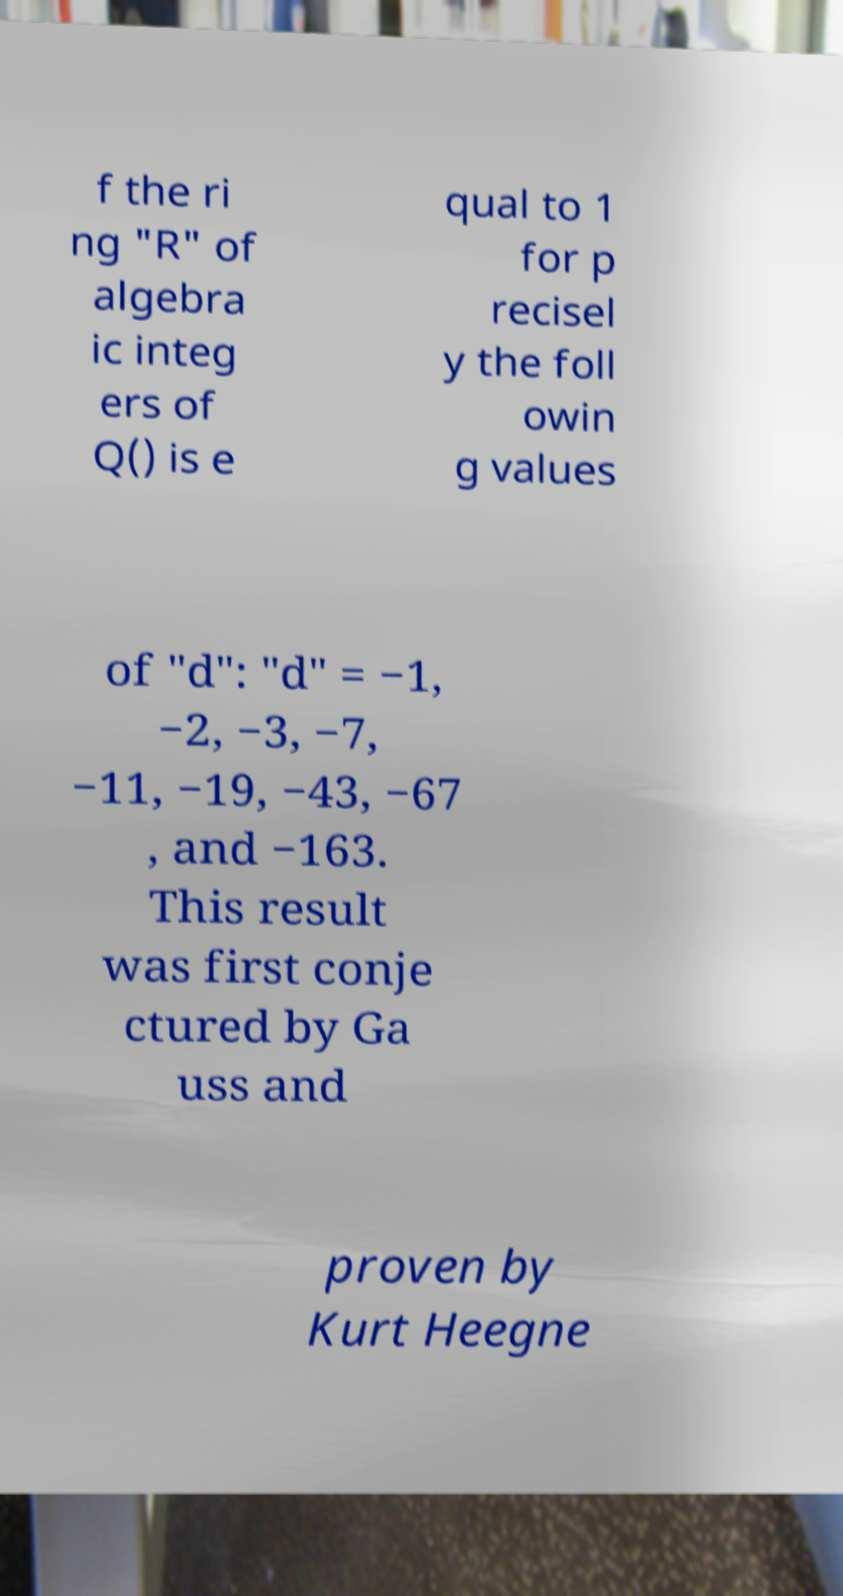Please identify and transcribe the text found in this image. f the ri ng "R" of algebra ic integ ers of Q() is e qual to 1 for p recisel y the foll owin g values of "d": "d" = −1, −2, −3, −7, −11, −19, −43, −67 , and −163. This result was first conje ctured by Ga uss and proven by Kurt Heegne 